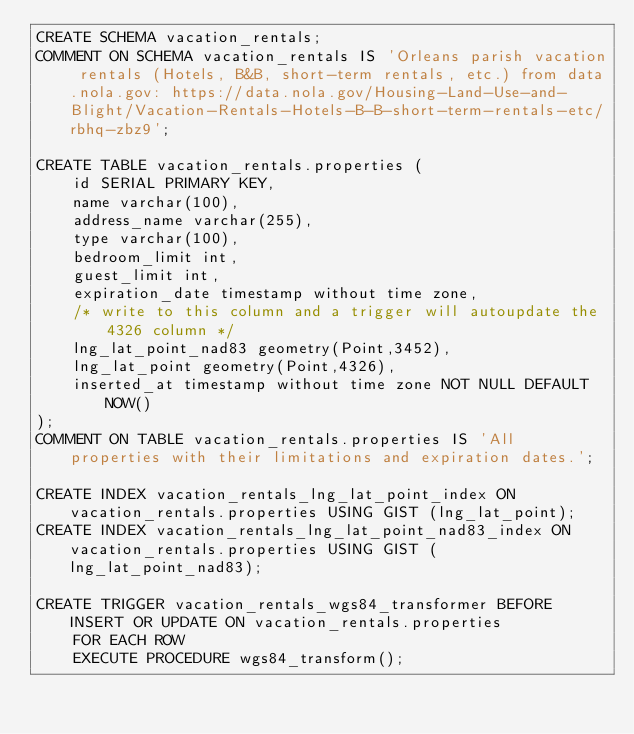Convert code to text. <code><loc_0><loc_0><loc_500><loc_500><_SQL_>CREATE SCHEMA vacation_rentals;
COMMENT ON SCHEMA vacation_rentals IS 'Orleans parish vacation rentals (Hotels, B&B, short-term rentals, etc.) from data.nola.gov: https://data.nola.gov/Housing-Land-Use-and-Blight/Vacation-Rentals-Hotels-B-B-short-term-rentals-etc/rbhq-zbz9';

CREATE TABLE vacation_rentals.properties (
    id SERIAL PRIMARY KEY,
    name varchar(100),
    address_name varchar(255),
    type varchar(100),
    bedroom_limit int,
    guest_limit int,
    expiration_date timestamp without time zone,
    /* write to this column and a trigger will autoupdate the 4326 column */
    lng_lat_point_nad83 geometry(Point,3452),
    lng_lat_point geometry(Point,4326),
    inserted_at timestamp without time zone NOT NULL DEFAULT NOW()
);
COMMENT ON TABLE vacation_rentals.properties IS 'All properties with their limitations and expiration dates.';

CREATE INDEX vacation_rentals_lng_lat_point_index ON vacation_rentals.properties USING GIST (lng_lat_point);
CREATE INDEX vacation_rentals_lng_lat_point_nad83_index ON vacation_rentals.properties USING GIST (lng_lat_point_nad83);

CREATE TRIGGER vacation_rentals_wgs84_transformer BEFORE INSERT OR UPDATE ON vacation_rentals.properties
    FOR EACH ROW
    EXECUTE PROCEDURE wgs84_transform();
</code> 